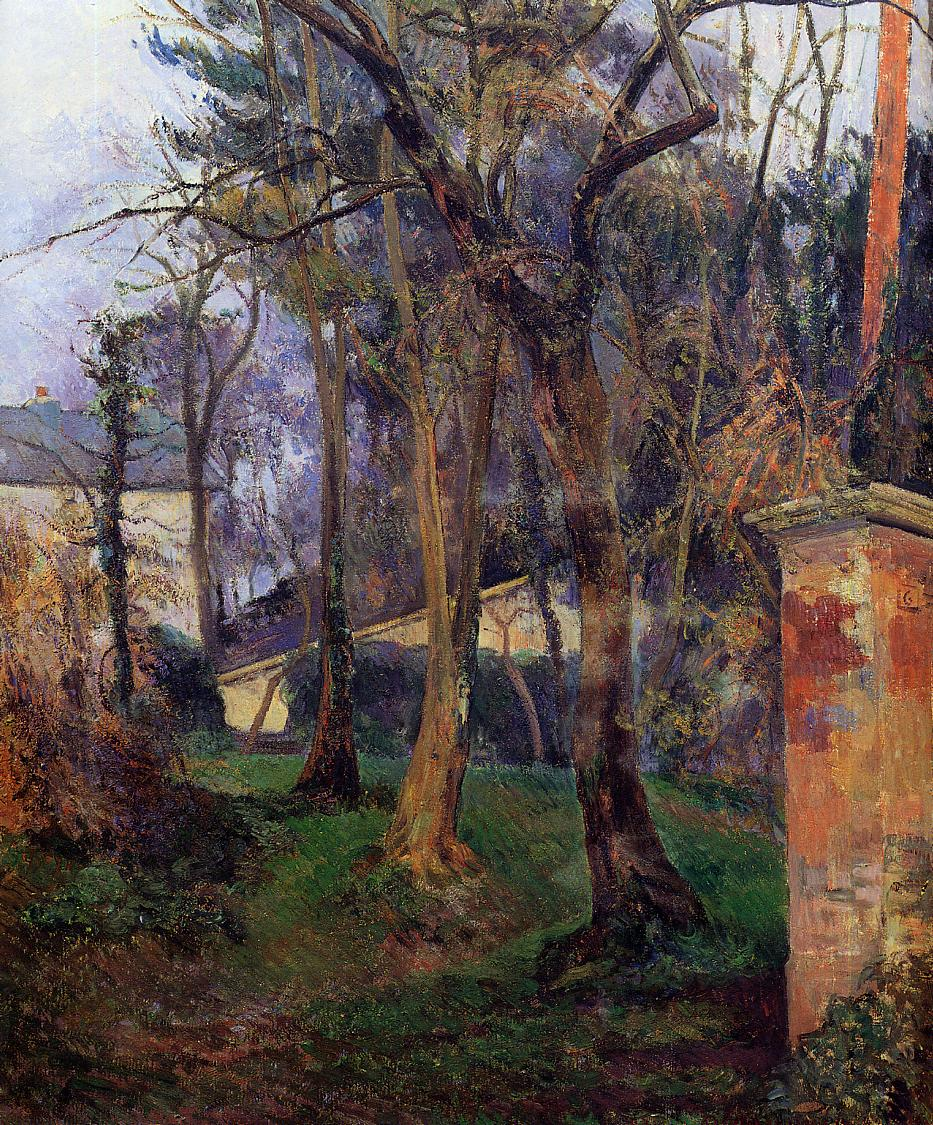Can you describe the mood of this painting? The mood of this painting is tranquil and contemplative. The impressionist style, with its soft brush strokes and delicate use of light and shadow, evokes a sense of peace and serenity. The overgrown garden suggests a natural, untouched beauty, while the subtle presence of the house hints at quiet, human habitation in harmony with nature. Overall, the painting imparts a feeling of calm and reflection. What time of year do you think this scene depicts? Based on the richness of the foliage and the vibrant greens, blues, and browns used in the painting, it seems likely that the scene depicts late spring or early summer. The trees are full and lush, and the garden is overgrown, suggesting a time of growth and abundance. Imagine strolling through this garden. What might you hear and smell? Strolling through this garden, one might hear the gentle rustle of leaves as a soft breeze moves through the trees. The occasional chirp of birds adds to the tranquil atmosphere. Depending on the plants, you might hear the quiet buzz of insects or the distant sound of water trickling from a nearby stream. The scents would be fresh and earthy, with the fragrance of flowers mingling with the rich aroma of damp soil and greenery. Perhaps the faint smell of a wood-burning stove from the house in the background adds a comforting touch. 